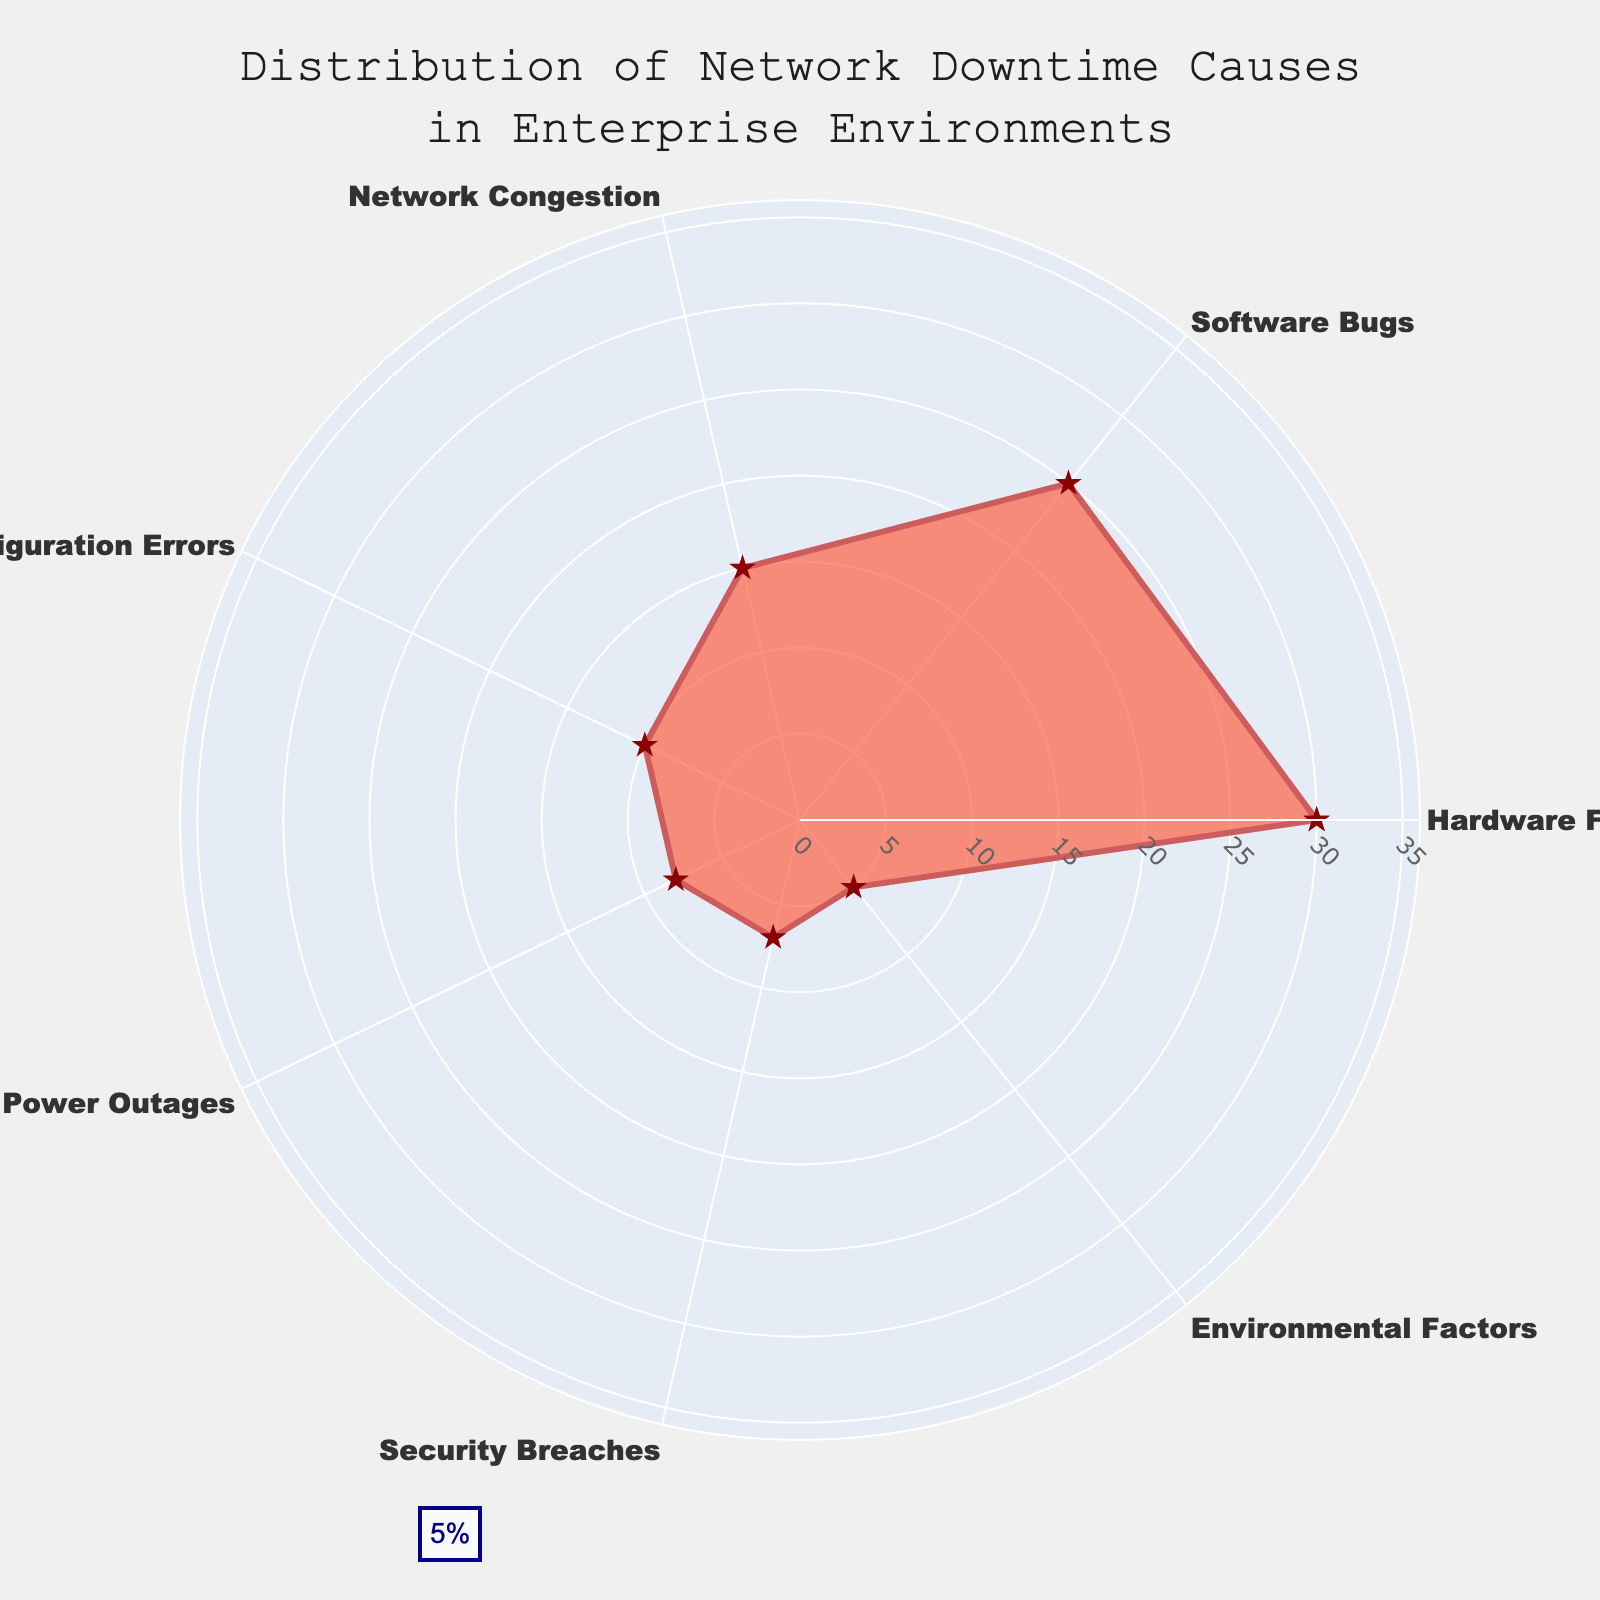What is the title of the radar chart? The title is prominently displayed at the top center of the radar chart. It reads: "Distribution of Network Downtime Causes in Enterprise Environments".
Answer: Distribution of Network Downtime Causes in Enterprise Environments Which category accounts for the highest percentage of network downtime? By looking at the length of each category's line from the center to the perimeter, you can see that Hardware Failure has the longest line, indicating it accounts for the highest percentage.
Answer: Hardware Failure How many categories have their percentages listed as an annotation near their values? Each category in the radar chart has a percentage value listed near it, including a repeating 'Hardware Failure' at the end to close the polygon. Counting these, we see there are a total of 7 categories with their percentages listed.
Answer: 7 What is the combined percentage of Network Congestion and Power Outages? Network Congestion accounts for 15% and Power Outages for 8%. Adding these together gives 15 + 8 = 23%.
Answer: 23% Which segment has the smallest percentage and what is it? Examining the radar chart reveals that the Environmental Factors segment is the smallest, as it has the shortest line from the center to the perimeter, marked 5%.
Answer: Environmental Factors, 5% How does the percentage of Security Breaches compare to Configuration Errors? Security Breaches account for 7% while Configuration Errors account for 10%. Comparing these, Security Breaches is smaller than Configuration Errors.
Answer: Security Breaches < Configuration Errors What is the mean percentage of all categories? Adding the values: 30 (Hardware Failure) + 25 (Software Bugs) + 15 (Network Congestion) + 10 (Configuration Errors) + 8 (Power Outages) + 7 (Security Breaches) + 5 (Environmental Factors) = 100. Dividing by the number of categories (7) gives 100 / 7 ≈ 14.29%.
Answer: ≈ 14.29% Which category is second highest in causing network downtime? By examining the lengths of the segments, Software Bugs has the second longest line from the center to the perimeter, behind Hardware Failure, indicating it as the second highest cause.
Answer: Software Bugs Is the sum of the percentages for Software Bugs and Environmental Factors greater than the percentage for Hardware Failure? Software Bugs (25%) + Environmental Factors (5%) = 30%. This sum is equal to the percentage for Hardware Failure (30%).
Answer: Equal How many categories have a percentage less than 10%? Examining the radar chart, the categories with less than 10% are Power Outages (8%), Security Breaches (7%), and Environmental Factors (5%). There are 3 categories with less than 10%.
Answer: 3 